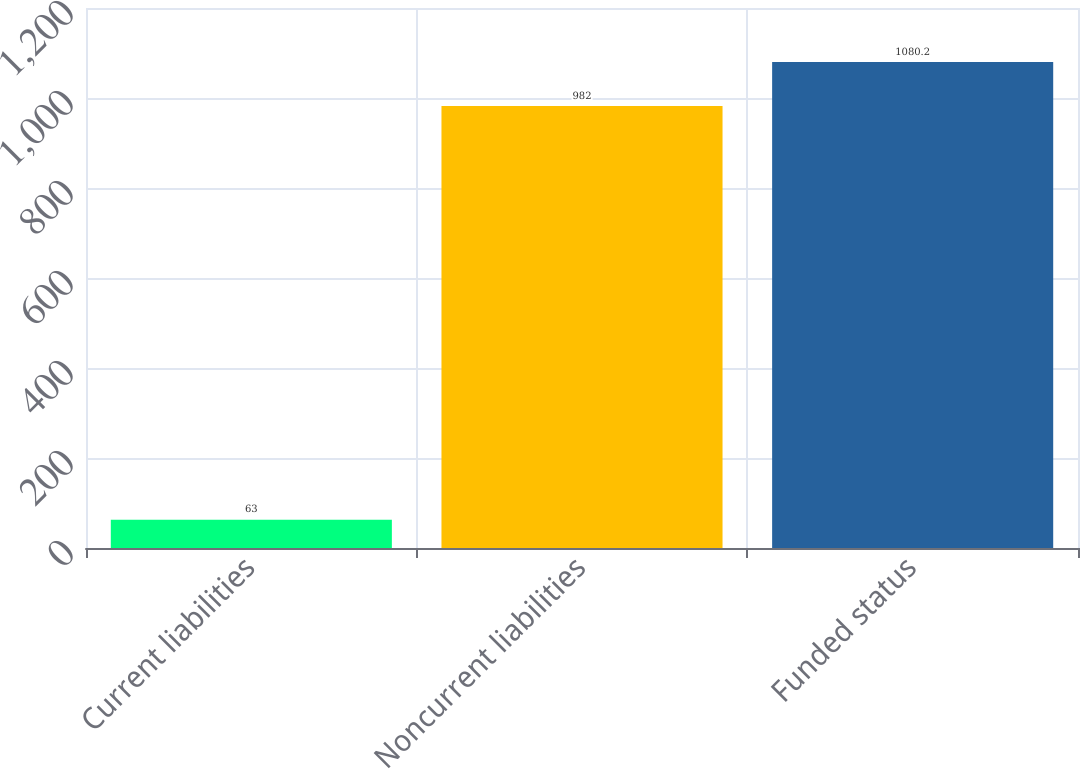Convert chart to OTSL. <chart><loc_0><loc_0><loc_500><loc_500><bar_chart><fcel>Current liabilities<fcel>Noncurrent liabilities<fcel>Funded status<nl><fcel>63<fcel>982<fcel>1080.2<nl></chart> 